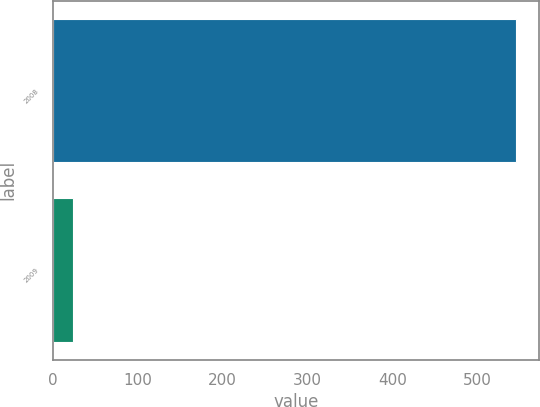<chart> <loc_0><loc_0><loc_500><loc_500><bar_chart><fcel>2008<fcel>2009<nl><fcel>545<fcel>24<nl></chart> 